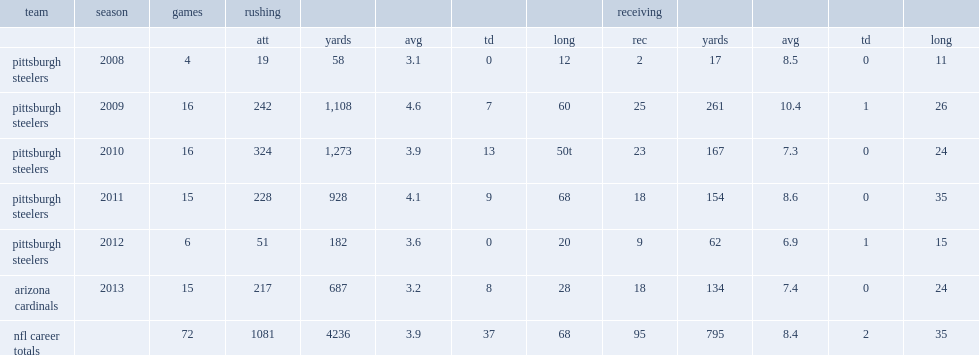How many rushing yards did rashard mendenhall finish the year with? 928.0. 